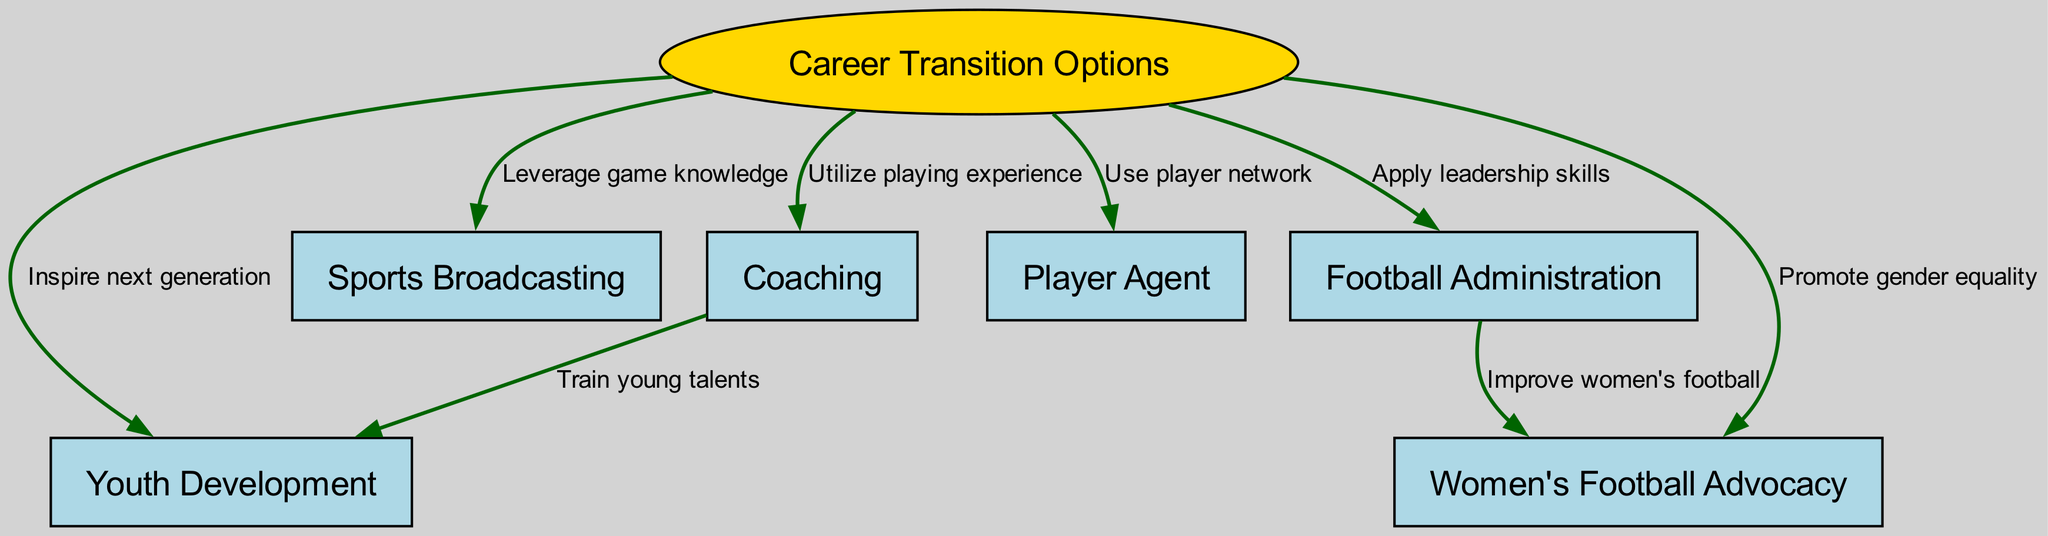What are the main nodes in the diagram? The main nodes are the different career transition options for retired professional footballers. By identifying the node labeled "Career Transition Options," we can see that it connects to various specific options such as Coaching, Sports Broadcasting, Football Administration, Player Agent, Youth Development, and Women's Football Advocacy.
Answer: Coaching, Sports Broadcasting, Football Administration, Player Agent, Youth Development, Women's Football Advocacy How many edges connect to "Coaching"? To determine the number of edges connecting to "Coaching," I will look for all edges that originate from the node labeled "2". There is one edge leading to "Youth Development" that indicates a relationship where coaching involves training young talents. Therefore, there is only one connecting edge.
Answer: 1 What does the edge from "Career Transition Options" to "Football Administration" represent? This edge indicates that pursuing a career in Football Administration allows retired players to apply their leadership skills. By tracing the edges visually, we see that the label on the edge between node "1" and node "4" states "Apply leadership skills."
Answer: Apply leadership skills Which career option involves promoting gender equality? I examine the nodes and edges in the diagram to find the specific career option associated with promoting gender equality. The edge from "Career Transition Options" to "Women's Football Advocacy" indicates that this option focuses on promoting gender equality in football. The label on the relevant edge confirms this connection.
Answer: Women's Football Advocacy What is the relationship between "Football Administration" and "Women's Football Advocacy"? By analyzing the connections in the diagram, I see that "Football Administration" has an edge leading to "Women's Football Advocacy." This edge indicates that football administration can improve women's football, demonstrating a relationship where effective management and support can lead to advancements in women's sports. The label on the edge confirms this interpretation.
Answer: Improve women's football Which transition option involves using a player network? To find the transition option involving a player network, I locate the edge that links "Career Transition Options" to "Player Agent." The edge indicates that this career option utilizes the player's established network to thrive in the industry.
Answer: Player Agent 